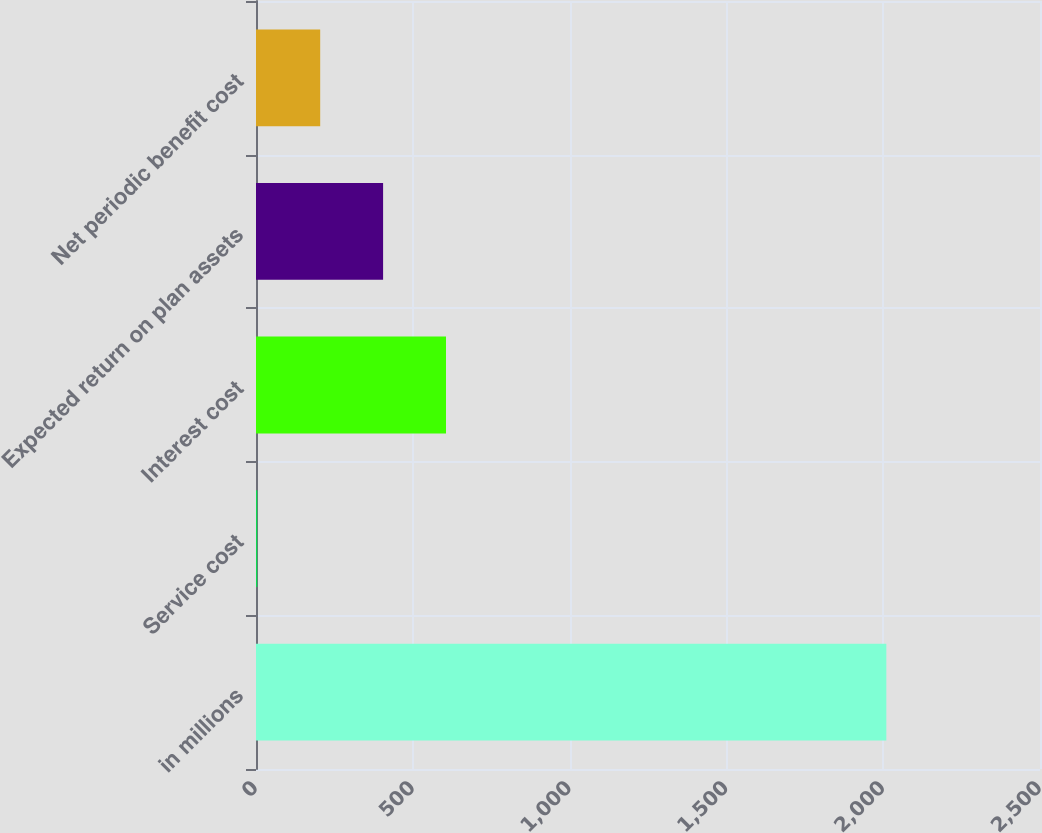Convert chart to OTSL. <chart><loc_0><loc_0><loc_500><loc_500><bar_chart><fcel>in millions<fcel>Service cost<fcel>Interest cost<fcel>Expected return on plan assets<fcel>Net periodic benefit cost<nl><fcel>2010<fcel>4.1<fcel>605.87<fcel>405.28<fcel>204.69<nl></chart> 